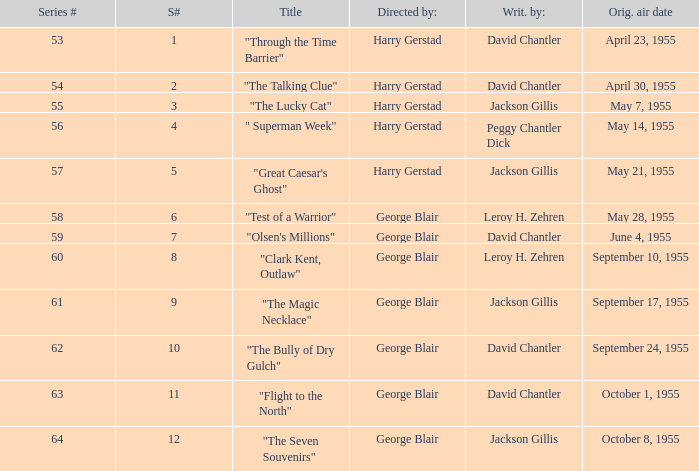Would you be able to parse every entry in this table? {'header': ['Series #', 'S#', 'Title', 'Directed by:', 'Writ. by:', 'Orig. air date'], 'rows': [['53', '1', '"Through the Time Barrier"', 'Harry Gerstad', 'David Chantler', 'April 23, 1955'], ['54', '2', '"The Talking Clue"', 'Harry Gerstad', 'David Chantler', 'April 30, 1955'], ['55', '3', '"The Lucky Cat"', 'Harry Gerstad', 'Jackson Gillis', 'May 7, 1955'], ['56', '4', '" Superman Week"', 'Harry Gerstad', 'Peggy Chantler Dick', 'May 14, 1955'], ['57', '5', '"Great Caesar\'s Ghost"', 'Harry Gerstad', 'Jackson Gillis', 'May 21, 1955'], ['58', '6', '"Test of a Warrior"', 'George Blair', 'Leroy H. Zehren', 'May 28, 1955'], ['59', '7', '"Olsen\'s Millions"', 'George Blair', 'David Chantler', 'June 4, 1955'], ['60', '8', '"Clark Kent, Outlaw"', 'George Blair', 'Leroy H. Zehren', 'September 10, 1955'], ['61', '9', '"The Magic Necklace"', 'George Blair', 'Jackson Gillis', 'September 17, 1955'], ['62', '10', '"The Bully of Dry Gulch"', 'George Blair', 'David Chantler', 'September 24, 1955'], ['63', '11', '"Flight to the North"', 'George Blair', 'David Chantler', 'October 1, 1955'], ['64', '12', '"The Seven Souvenirs"', 'George Blair', 'Jackson Gillis', 'October 8, 1955']]} What is the lowest number of series? 53.0. 